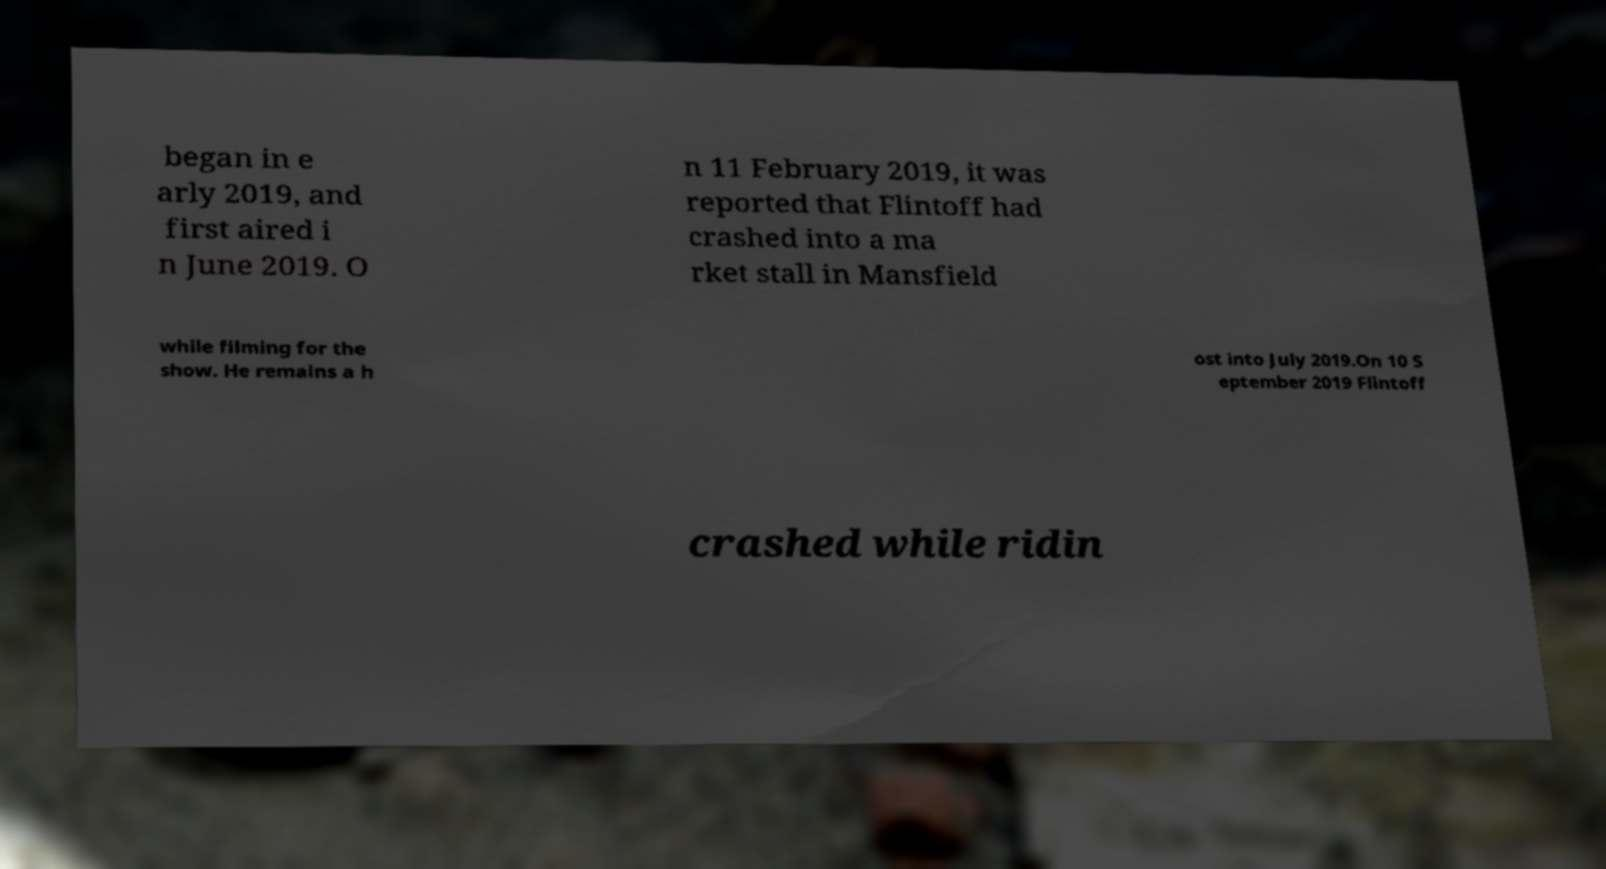There's text embedded in this image that I need extracted. Can you transcribe it verbatim? began in e arly 2019, and first aired i n June 2019. O n 11 February 2019, it was reported that Flintoff had crashed into a ma rket stall in Mansfield while filming for the show. He remains a h ost into July 2019.On 10 S eptember 2019 Flintoff crashed while ridin 